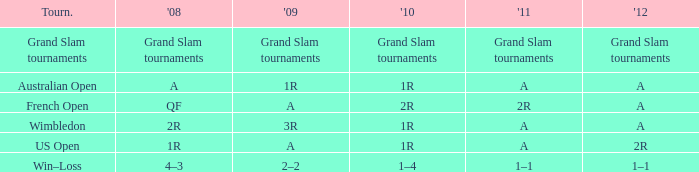Name the 2010 for 2011 of a and 2008 of 1r 1R. 